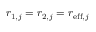Convert formula to latex. <formula><loc_0><loc_0><loc_500><loc_500>r _ { 1 , j } = r _ { 2 , j } = r _ { e f f , j }</formula> 